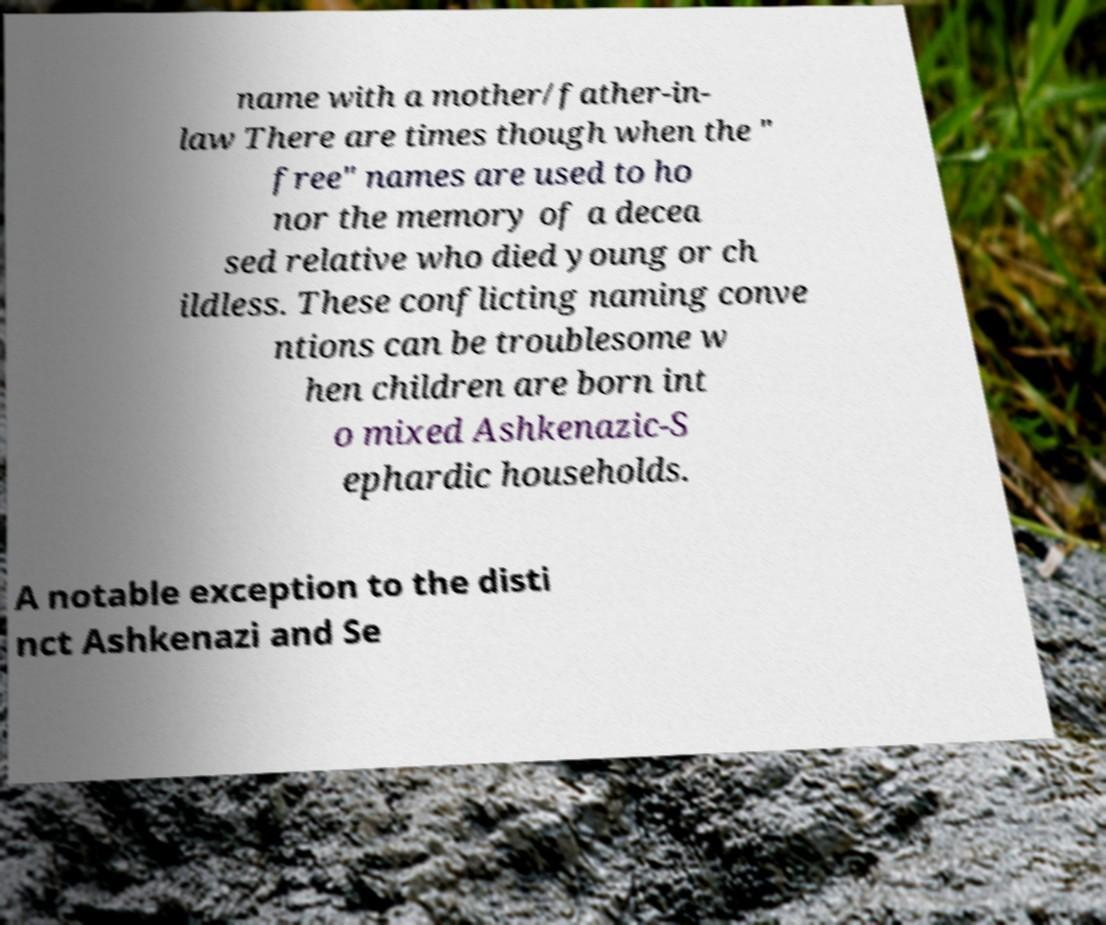What messages or text are displayed in this image? I need them in a readable, typed format. name with a mother/father-in- law There are times though when the " free" names are used to ho nor the memory of a decea sed relative who died young or ch ildless. These conflicting naming conve ntions can be troublesome w hen children are born int o mixed Ashkenazic-S ephardic households. A notable exception to the disti nct Ashkenazi and Se 